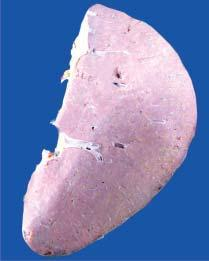does line of demarcation between gangrenous segment and the viable bowel show presence of plae waxy translucency in a map-like pattern?
Answer the question using a single word or phrase. No 